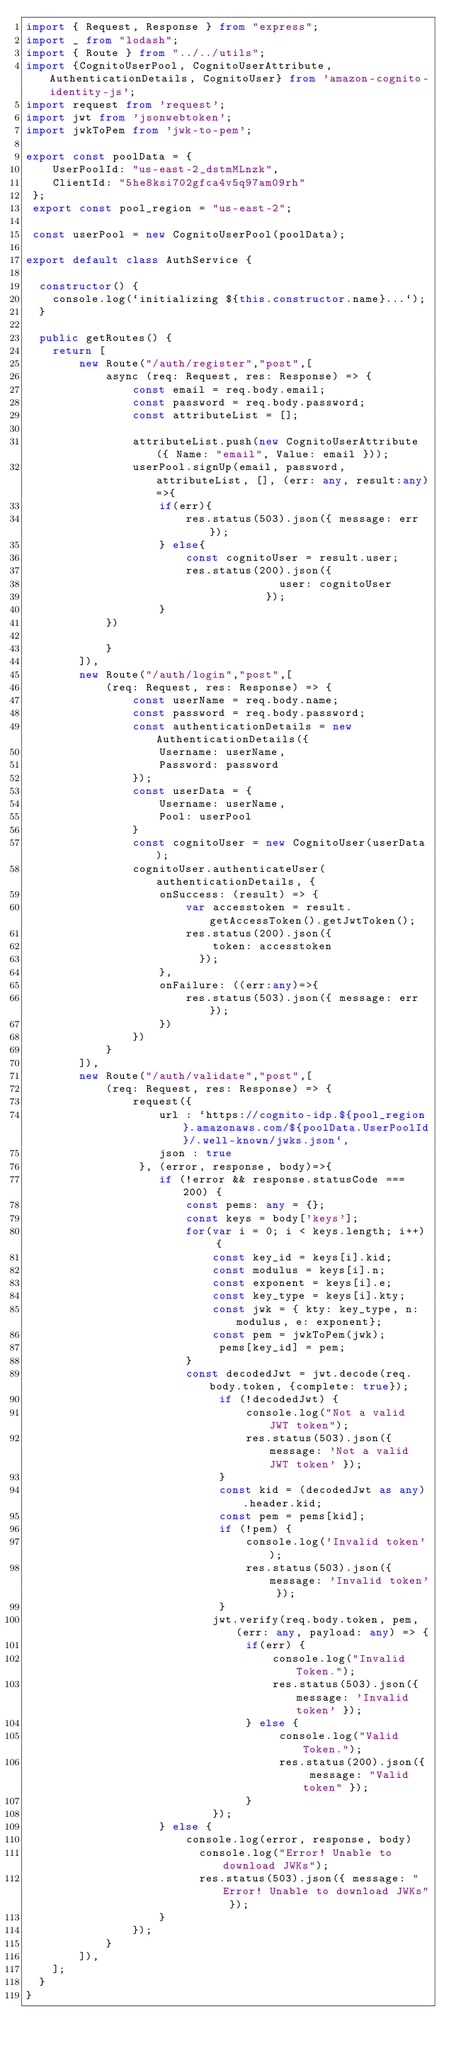<code> <loc_0><loc_0><loc_500><loc_500><_TypeScript_>import { Request, Response } from "express";
import _ from "lodash";
import { Route } from "../../utils";
import {CognitoUserPool, CognitoUserAttribute, AuthenticationDetails, CognitoUser} from 'amazon-cognito-identity-js';
import request from 'request';
import jwt from 'jsonwebtoken';
import jwkToPem from 'jwk-to-pem';

export const poolData = {
    UserPoolId: "us-east-2_dstmMLnzk",
    ClientId: "5he8ksi702gfca4v5q97am09rh"
 };
 export const pool_region = "us-east-2";
 
 const userPool = new CognitoUserPool(poolData);

export default class AuthService {
    
  constructor() {
    console.log(`initializing ${this.constructor.name}...`);
  }

  public getRoutes() {
    return [
        new Route("/auth/register","post",[
            async (req: Request, res: Response) => {
                const email = req.body.email;
                const password = req.body.password;
                const attributeList = [];
            
                attributeList.push(new CognitoUserAttribute({ Name: "email", Value: email }));
                userPool.signUp(email, password, attributeList, [], (err: any, result:any)=>{
                    if(err){
                        res.status(503).json({ message: err });
                    } else{
                        const cognitoUser = result.user;
                        res.status(200).json({
                                      user: cognitoUser
                                    });
                    }
            })

            }
        ]),
        new Route("/auth/login","post",[
            (req: Request, res: Response) => {
                const userName = req.body.name;
                const password = req.body.password;
                const authenticationDetails = new AuthenticationDetails({
                    Username: userName,
                    Password: password
                });
                const userData = {
                    Username: userName,
                    Pool: userPool
                }
                const cognitoUser = new CognitoUser(userData);
                cognitoUser.authenticateUser(authenticationDetails, {
                    onSuccess: (result) => {
                        var accesstoken = result.getAccessToken().getJwtToken();
                        res.status(200).json({
                            token: accesstoken
                          });
                    },
                    onFailure: ((err:any)=>{
                        res.status(503).json({ message: err });
                    })
                })
            }
        ]),
        new Route("/auth/validate","post",[
            (req: Request, res: Response) => {
                request({
                    url : `https://cognito-idp.${pool_region}.amazonaws.com/${poolData.UserPoolId}/.well-known/jwks.json`,
                    json : true
                 }, (error, response, body)=>{
                    if (!error && response.statusCode === 200) {
                        const pems: any = {};
                        const keys = body['keys'];
                        for(var i = 0; i < keys.length; i++) {
                            const key_id = keys[i].kid;
                            const modulus = keys[i].n;
                            const exponent = keys[i].e;
                            const key_type = keys[i].kty;
                            const jwk = { kty: key_type, n: modulus, e: exponent};
                            const pem = jwkToPem(jwk);
                             pems[key_id] = pem;
                        }
                        const decodedJwt = jwt.decode(req.body.token, {complete: true});
                             if (!decodedJwt) {
                                 console.log("Not a valid JWT token");
                                 res.status(503).json({ message: 'Not a valid JWT token' });
                             }
                             const kid = (decodedJwt as any).header.kid;
                             const pem = pems[kid];
                             if (!pem) {
                                 console.log('Invalid token');
                                 res.status(503).json({ message: 'Invalid token' });
                             }
                            jwt.verify(req.body.token, pem, (err: any, payload: any) => {
                                 if(err) {
                                     console.log("Invalid Token.");
                                     res.status(503).json({ message: 'Invalid token' });
                                 } else {
                                      console.log("Valid Token.");
                                      res.status(200).json({ message: "Valid token" });
                                 }
                            });
                    } else {
                        console.log(error, response, body)
                          console.log("Error! Unable to download JWKs");
                          res.status(503).json({ message: "Error! Unable to download JWKs" });
                    }
                });
            }
        ]),
    ];
  }
}
</code> 